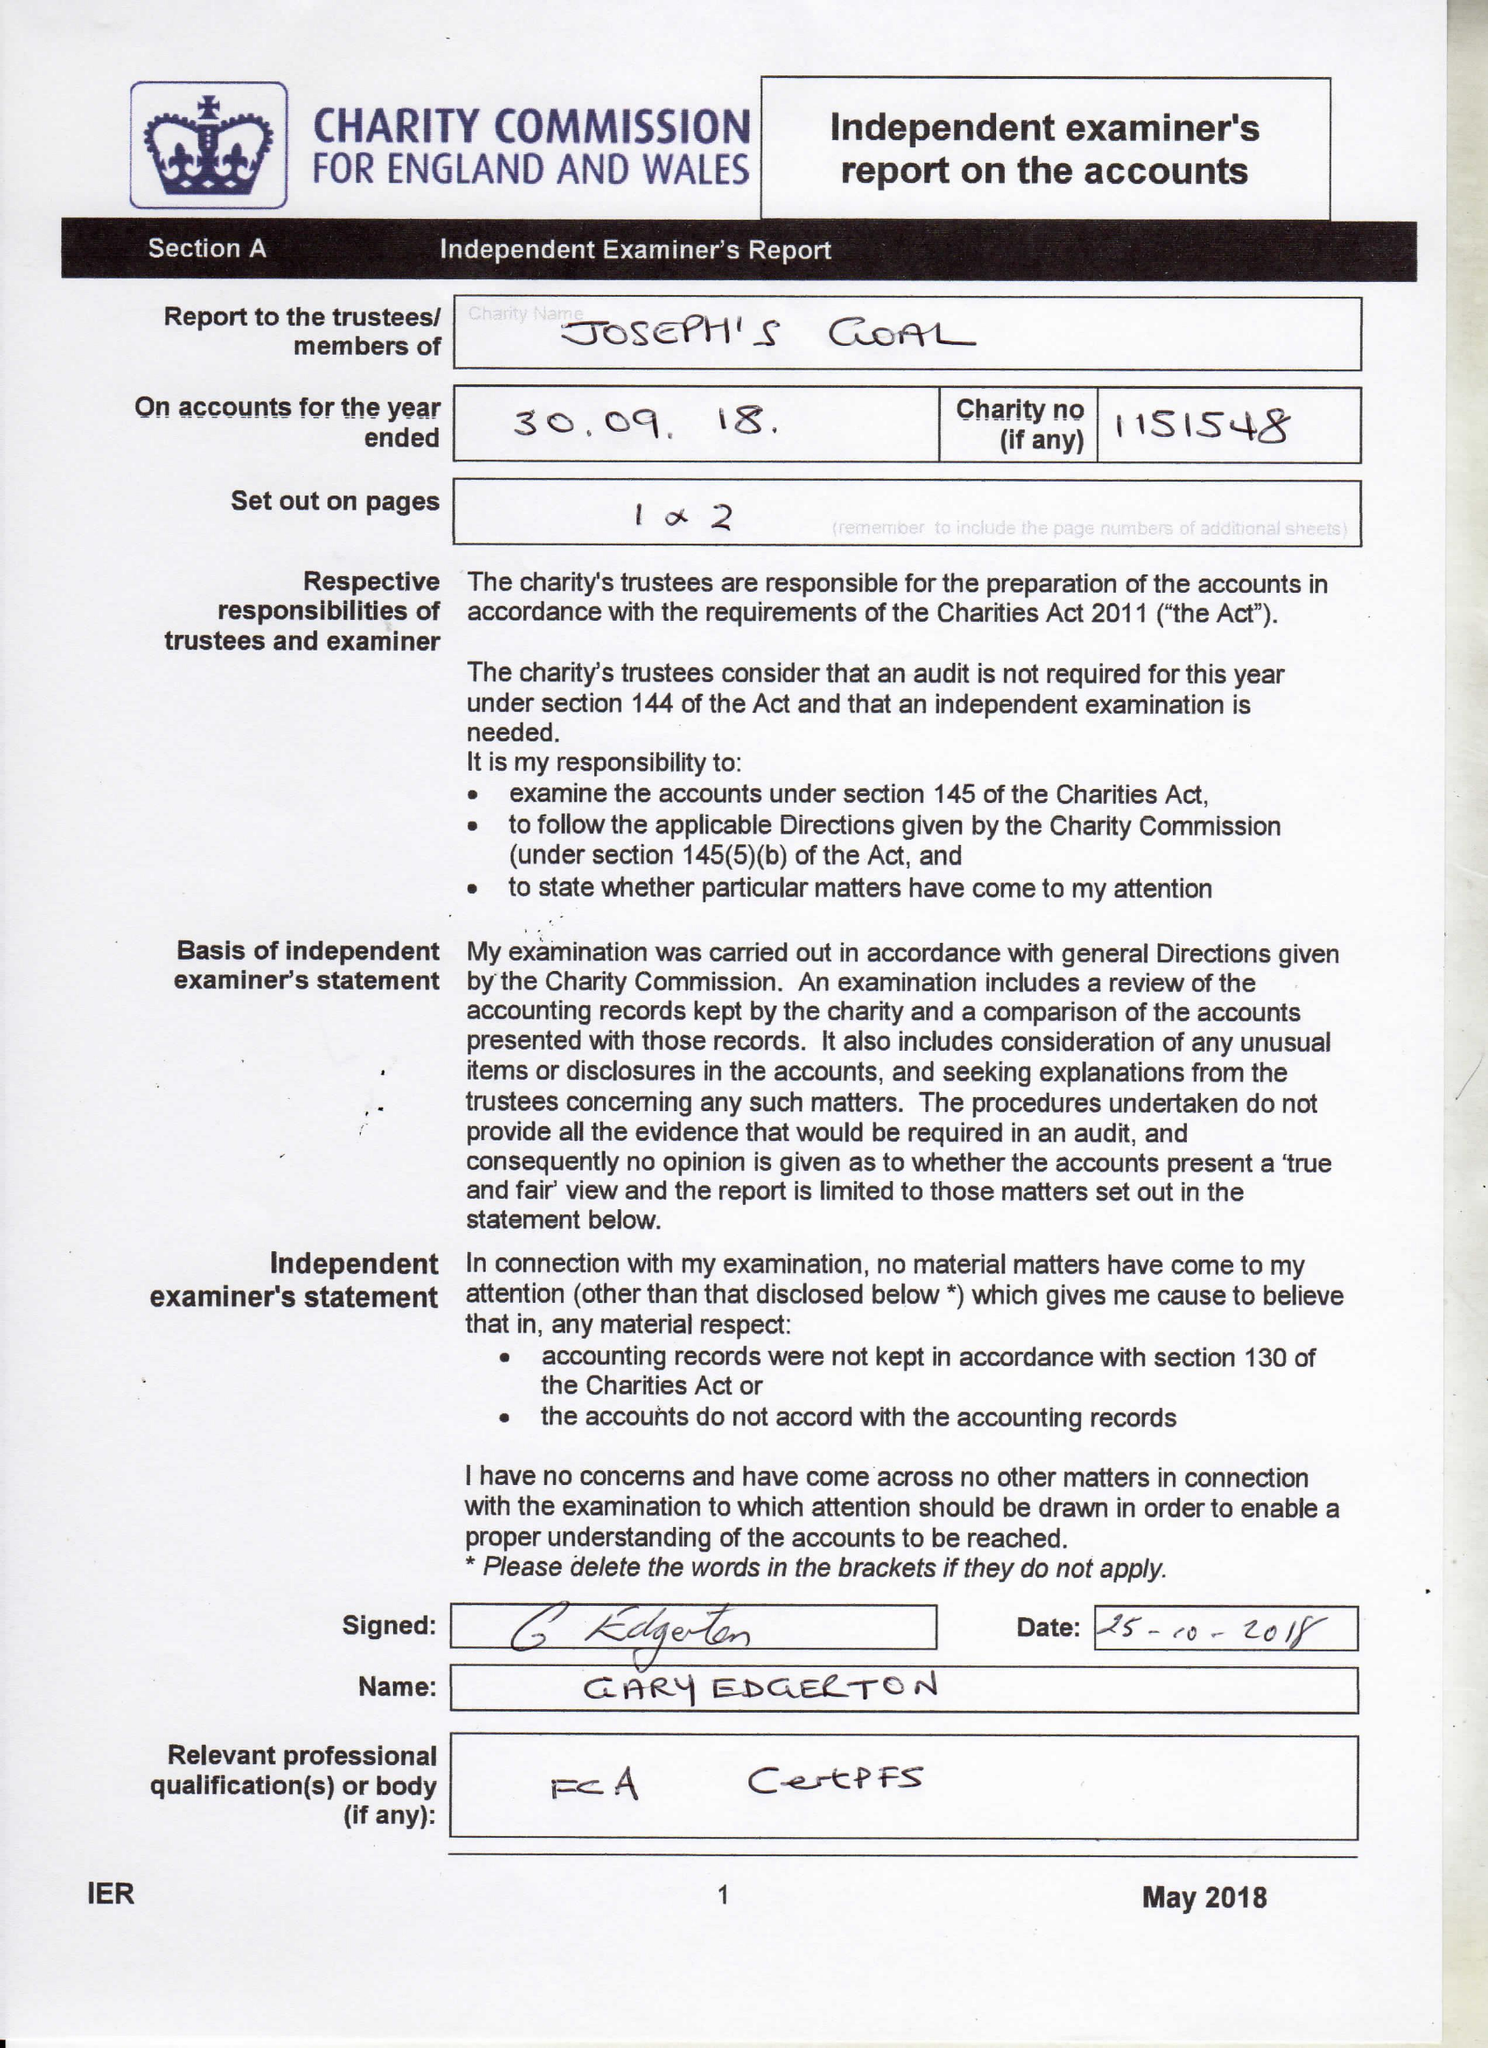What is the value for the address__postcode?
Answer the question using a single word or phrase. WN5 8QB 